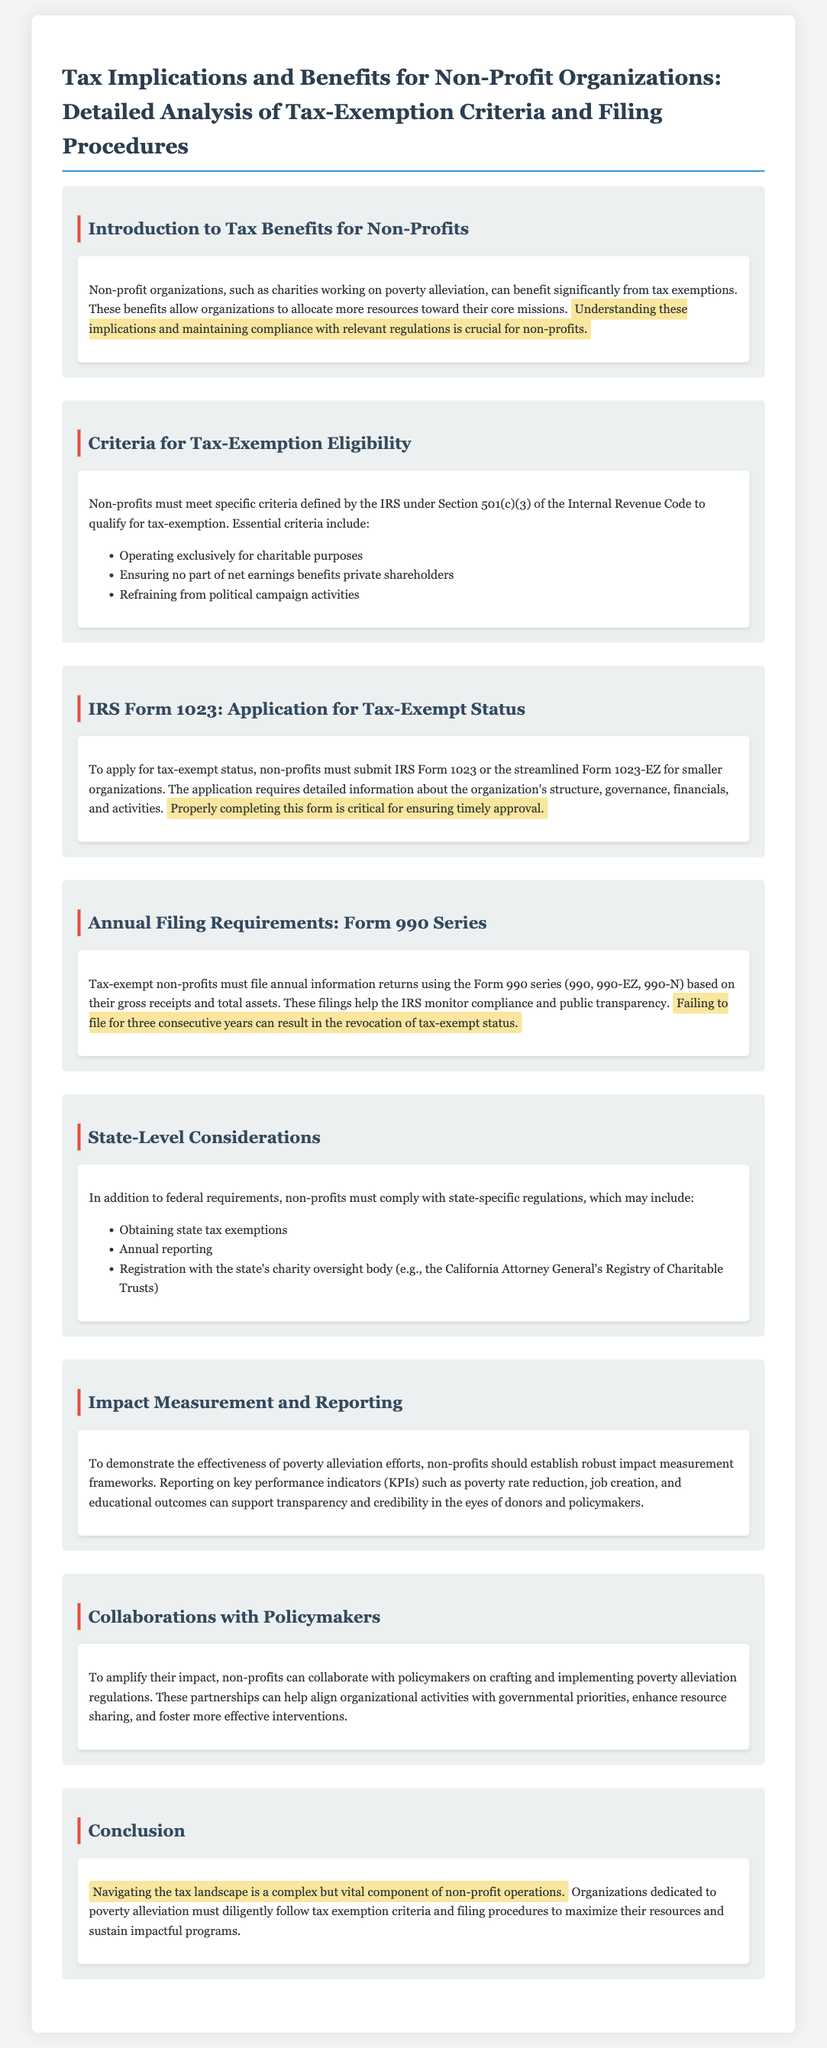What are the criteria for tax-exemption eligibility? The criteria include operating exclusively for charitable purposes, ensuring no part of net earnings benefits private shareholders, and refraining from political campaign activities.
Answer: Operating exclusively for charitable purposes, ensuring no part of net earnings benefits private shareholders, refraining from political campaign activities Which IRS form is used for tax-exempt status application? Non-profits must submit IRS Form 1023 or the streamlined Form 1023-EZ for smaller organizations.
Answer: IRS Form 1023 or Form 1023-EZ What is the consequence of failing to file for three consecutive years? Failing to file for three consecutive years can result in the revocation of tax-exempt status.
Answer: Revocation of tax-exempt status What does the annual filing requirement help monitor? The filings help the IRS monitor compliance and public transparency.
Answer: Compliance and public transparency What should non-profits establish to demonstrate effectiveness? Non-profits should establish robust impact measurement frameworks to demonstrate effectiveness.
Answer: Robust impact measurement frameworks How can non-profits amplify their impact? Non-profits can collaborate with policymakers on crafting and implementing poverty alleviation regulations.
Answer: Collaborate with policymakers What must non-profits comply with in addition to federal requirements? Non-profits must comply with state-specific regulations.
Answer: State-specific regulations What must non-profits report on to support transparency? Non-profits should report on key performance indicators (KPIs) such as poverty rate reduction, job creation, and educational outcomes.
Answer: Key performance indicators (KPIs) 